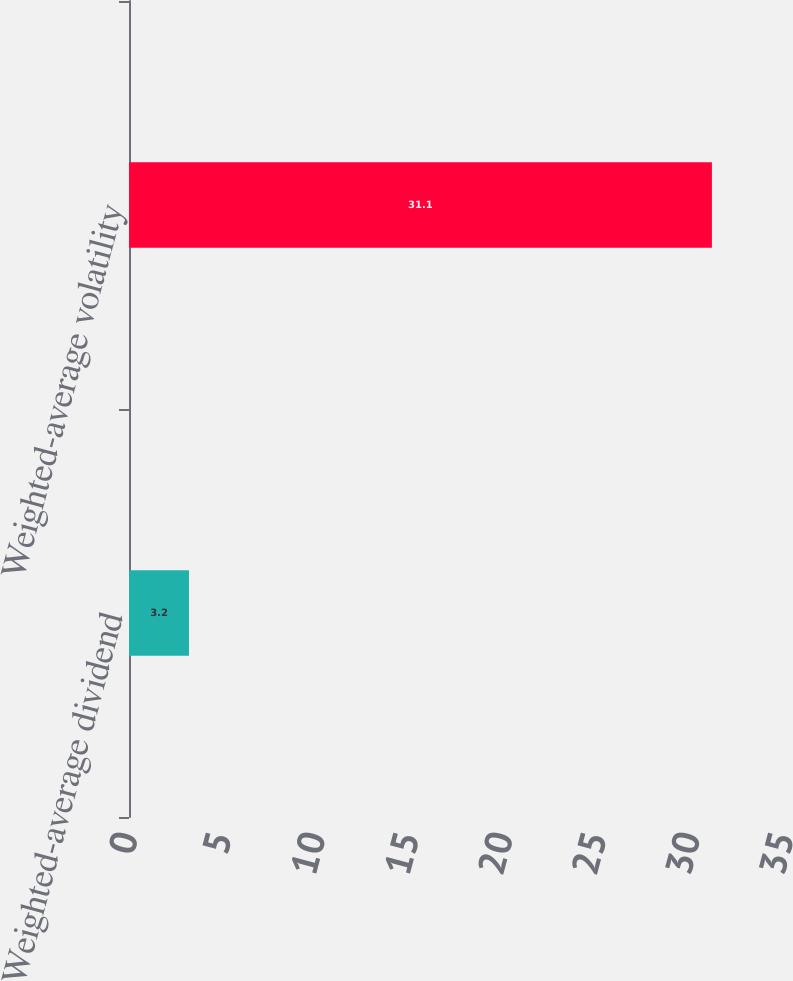<chart> <loc_0><loc_0><loc_500><loc_500><bar_chart><fcel>Weighted-average dividend<fcel>Weighted-average volatility<nl><fcel>3.2<fcel>31.1<nl></chart> 